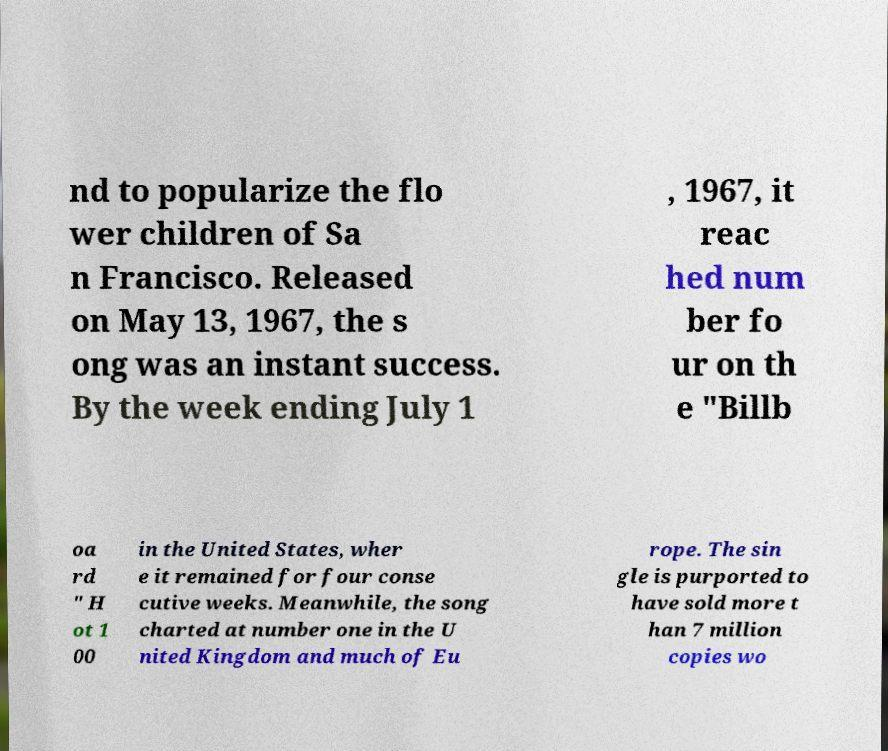I need the written content from this picture converted into text. Can you do that? nd to popularize the flo wer children of Sa n Francisco. Released on May 13, 1967, the s ong was an instant success. By the week ending July 1 , 1967, it reac hed num ber fo ur on th e "Billb oa rd " H ot 1 00 in the United States, wher e it remained for four conse cutive weeks. Meanwhile, the song charted at number one in the U nited Kingdom and much of Eu rope. The sin gle is purported to have sold more t han 7 million copies wo 